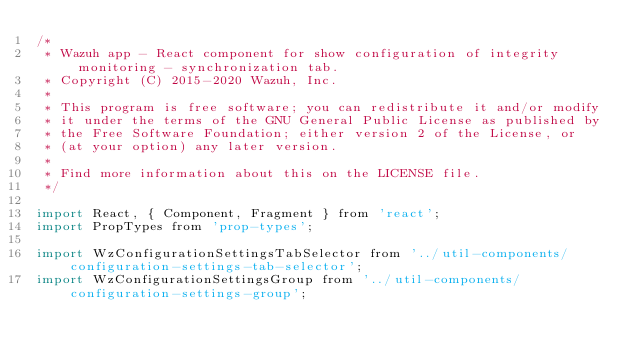Convert code to text. <code><loc_0><loc_0><loc_500><loc_500><_JavaScript_>/*
 * Wazuh app - React component for show configuration of integrity monitoring - synchronization tab.
 * Copyright (C) 2015-2020 Wazuh, Inc.
 *
 * This program is free software; you can redistribute it and/or modify
 * it under the terms of the GNU General Public License as published by
 * the Free Software Foundation; either version 2 of the License, or
 * (at your option) any later version.
 *
 * Find more information about this on the LICENSE file.
 */

import React, { Component, Fragment } from 'react';
import PropTypes from 'prop-types';

import WzConfigurationSettingsTabSelector from '../util-components/configuration-settings-tab-selector';
import WzConfigurationSettingsGroup from '../util-components/configuration-settings-group';</code> 